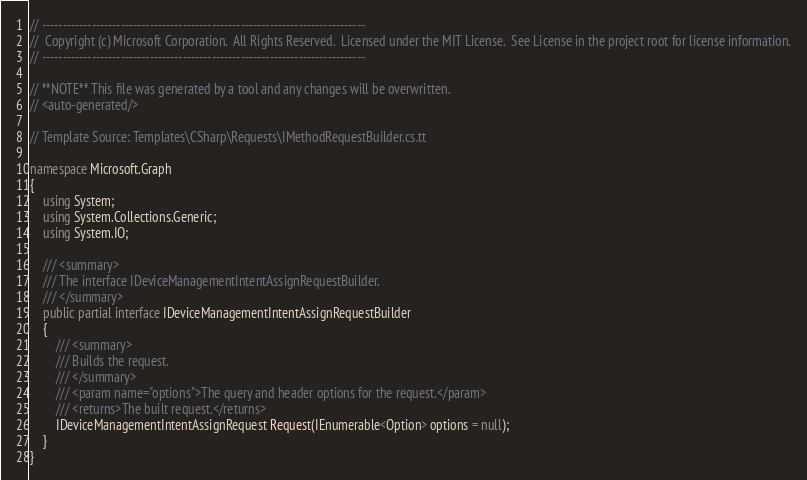Convert code to text. <code><loc_0><loc_0><loc_500><loc_500><_C#_>// ------------------------------------------------------------------------------
//  Copyright (c) Microsoft Corporation.  All Rights Reserved.  Licensed under the MIT License.  See License in the project root for license information.
// ------------------------------------------------------------------------------

// **NOTE** This file was generated by a tool and any changes will be overwritten.
// <auto-generated/>

// Template Source: Templates\CSharp\Requests\IMethodRequestBuilder.cs.tt

namespace Microsoft.Graph
{
    using System;
    using System.Collections.Generic;
    using System.IO;

    /// <summary>
    /// The interface IDeviceManagementIntentAssignRequestBuilder.
    /// </summary>
    public partial interface IDeviceManagementIntentAssignRequestBuilder
    {
        /// <summary>
        /// Builds the request.
        /// </summary>
        /// <param name="options">The query and header options for the request.</param>
        /// <returns>The built request.</returns>
        IDeviceManagementIntentAssignRequest Request(IEnumerable<Option> options = null);
    }
}
</code> 